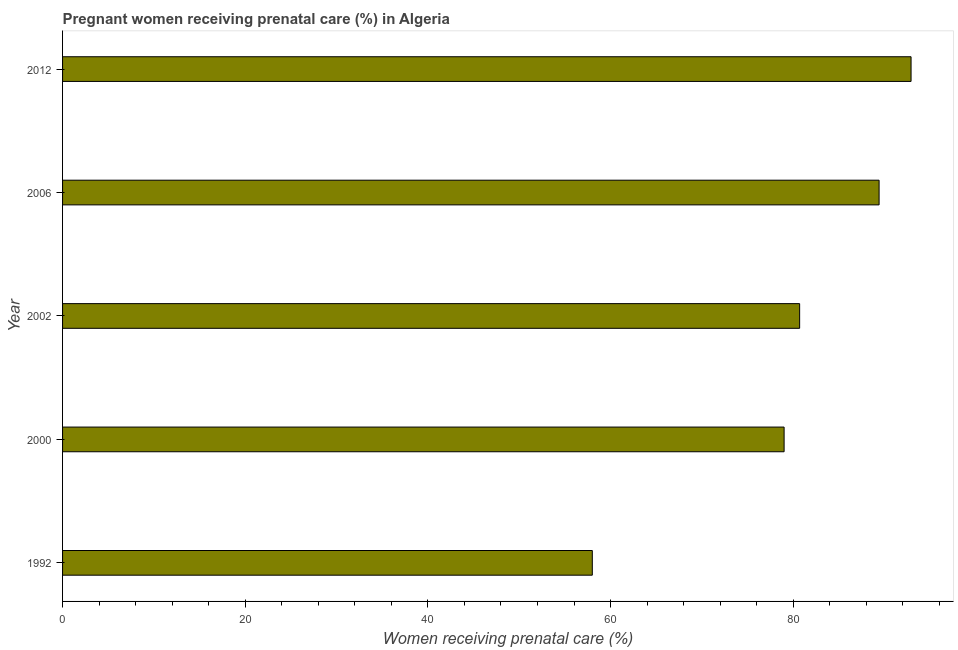Does the graph contain any zero values?
Your response must be concise. No. Does the graph contain grids?
Offer a very short reply. No. What is the title of the graph?
Make the answer very short. Pregnant women receiving prenatal care (%) in Algeria. What is the label or title of the X-axis?
Provide a short and direct response. Women receiving prenatal care (%). Across all years, what is the maximum percentage of pregnant women receiving prenatal care?
Your answer should be very brief. 92.9. In which year was the percentage of pregnant women receiving prenatal care maximum?
Your response must be concise. 2012. In which year was the percentage of pregnant women receiving prenatal care minimum?
Ensure brevity in your answer.  1992. What is the difference between the percentage of pregnant women receiving prenatal care in 2000 and 2002?
Offer a terse response. -1.7. What is the average percentage of pregnant women receiving prenatal care per year?
Your response must be concise. 80. What is the median percentage of pregnant women receiving prenatal care?
Your answer should be compact. 80.7. In how many years, is the percentage of pregnant women receiving prenatal care greater than 24 %?
Provide a succinct answer. 5. Do a majority of the years between 1992 and 2006 (inclusive) have percentage of pregnant women receiving prenatal care greater than 56 %?
Provide a short and direct response. Yes. What is the ratio of the percentage of pregnant women receiving prenatal care in 1992 to that in 2006?
Your response must be concise. 0.65. Is the percentage of pregnant women receiving prenatal care in 2000 less than that in 2006?
Offer a terse response. Yes. Is the sum of the percentage of pregnant women receiving prenatal care in 1992 and 2006 greater than the maximum percentage of pregnant women receiving prenatal care across all years?
Your answer should be compact. Yes. What is the difference between the highest and the lowest percentage of pregnant women receiving prenatal care?
Keep it short and to the point. 34.9. How many years are there in the graph?
Your response must be concise. 5. What is the difference between two consecutive major ticks on the X-axis?
Give a very brief answer. 20. What is the Women receiving prenatal care (%) of 2000?
Your answer should be very brief. 79. What is the Women receiving prenatal care (%) of 2002?
Your answer should be very brief. 80.7. What is the Women receiving prenatal care (%) in 2006?
Provide a succinct answer. 89.4. What is the Women receiving prenatal care (%) in 2012?
Ensure brevity in your answer.  92.9. What is the difference between the Women receiving prenatal care (%) in 1992 and 2002?
Offer a very short reply. -22.7. What is the difference between the Women receiving prenatal care (%) in 1992 and 2006?
Ensure brevity in your answer.  -31.4. What is the difference between the Women receiving prenatal care (%) in 1992 and 2012?
Ensure brevity in your answer.  -34.9. What is the difference between the Women receiving prenatal care (%) in 2000 and 2002?
Your answer should be compact. -1.7. What is the difference between the Women receiving prenatal care (%) in 2000 and 2006?
Give a very brief answer. -10.4. What is the difference between the Women receiving prenatal care (%) in 2002 and 2006?
Your answer should be compact. -8.7. What is the difference between the Women receiving prenatal care (%) in 2006 and 2012?
Offer a very short reply. -3.5. What is the ratio of the Women receiving prenatal care (%) in 1992 to that in 2000?
Offer a very short reply. 0.73. What is the ratio of the Women receiving prenatal care (%) in 1992 to that in 2002?
Provide a succinct answer. 0.72. What is the ratio of the Women receiving prenatal care (%) in 1992 to that in 2006?
Ensure brevity in your answer.  0.65. What is the ratio of the Women receiving prenatal care (%) in 1992 to that in 2012?
Give a very brief answer. 0.62. What is the ratio of the Women receiving prenatal care (%) in 2000 to that in 2006?
Your answer should be very brief. 0.88. What is the ratio of the Women receiving prenatal care (%) in 2002 to that in 2006?
Ensure brevity in your answer.  0.9. What is the ratio of the Women receiving prenatal care (%) in 2002 to that in 2012?
Offer a terse response. 0.87. 